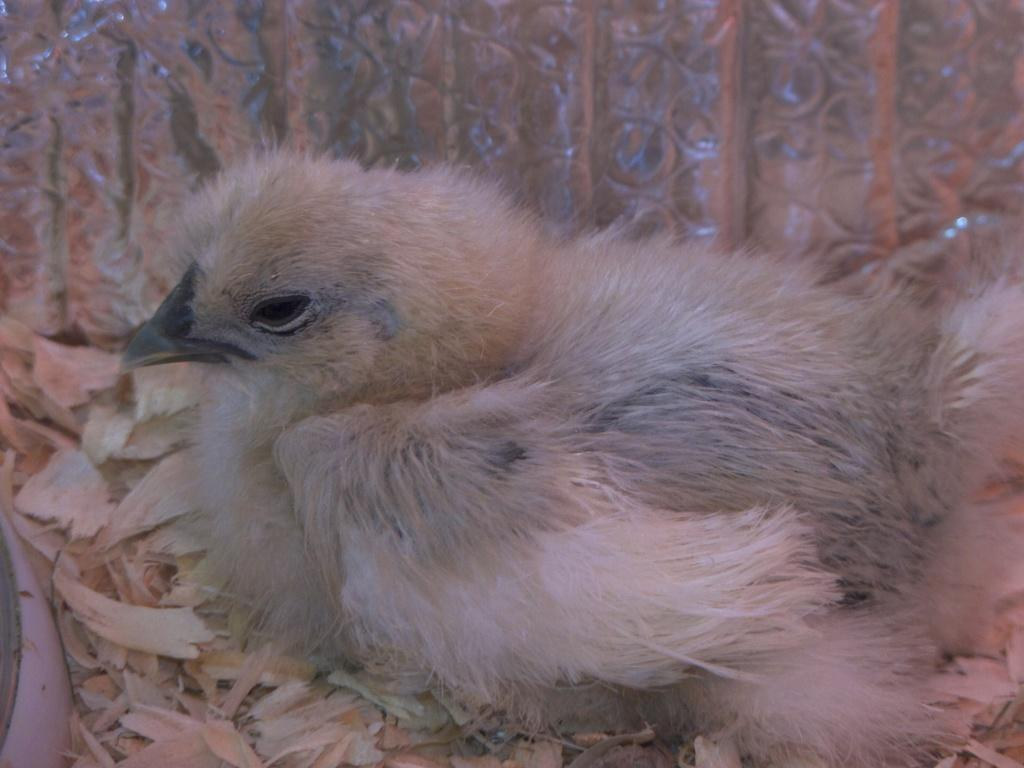What type of animal is present in the image? There is a bird in the image. Where is the bird located in the image? The bird is on the surface in the image. Can you see any orange squirrels or sheep in the image? No, there are no orange squirrels or sheep present in the image. The image only features a bird on the surface. 